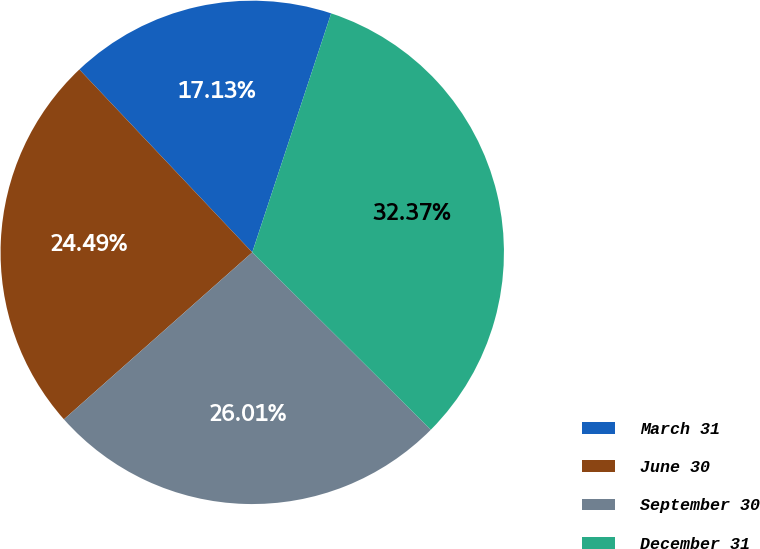Convert chart to OTSL. <chart><loc_0><loc_0><loc_500><loc_500><pie_chart><fcel>March 31<fcel>June 30<fcel>September 30<fcel>December 31<nl><fcel>17.13%<fcel>24.49%<fcel>26.01%<fcel>32.37%<nl></chart> 